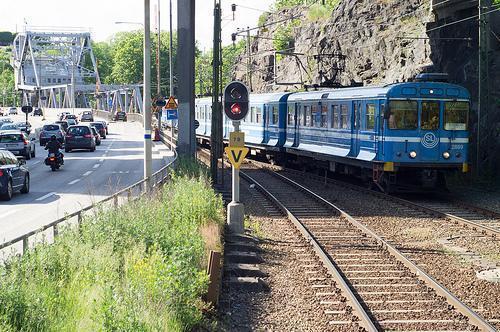How many trains are there?
Give a very brief answer. 1. How many train tracks are empty?
Give a very brief answer. 1. 